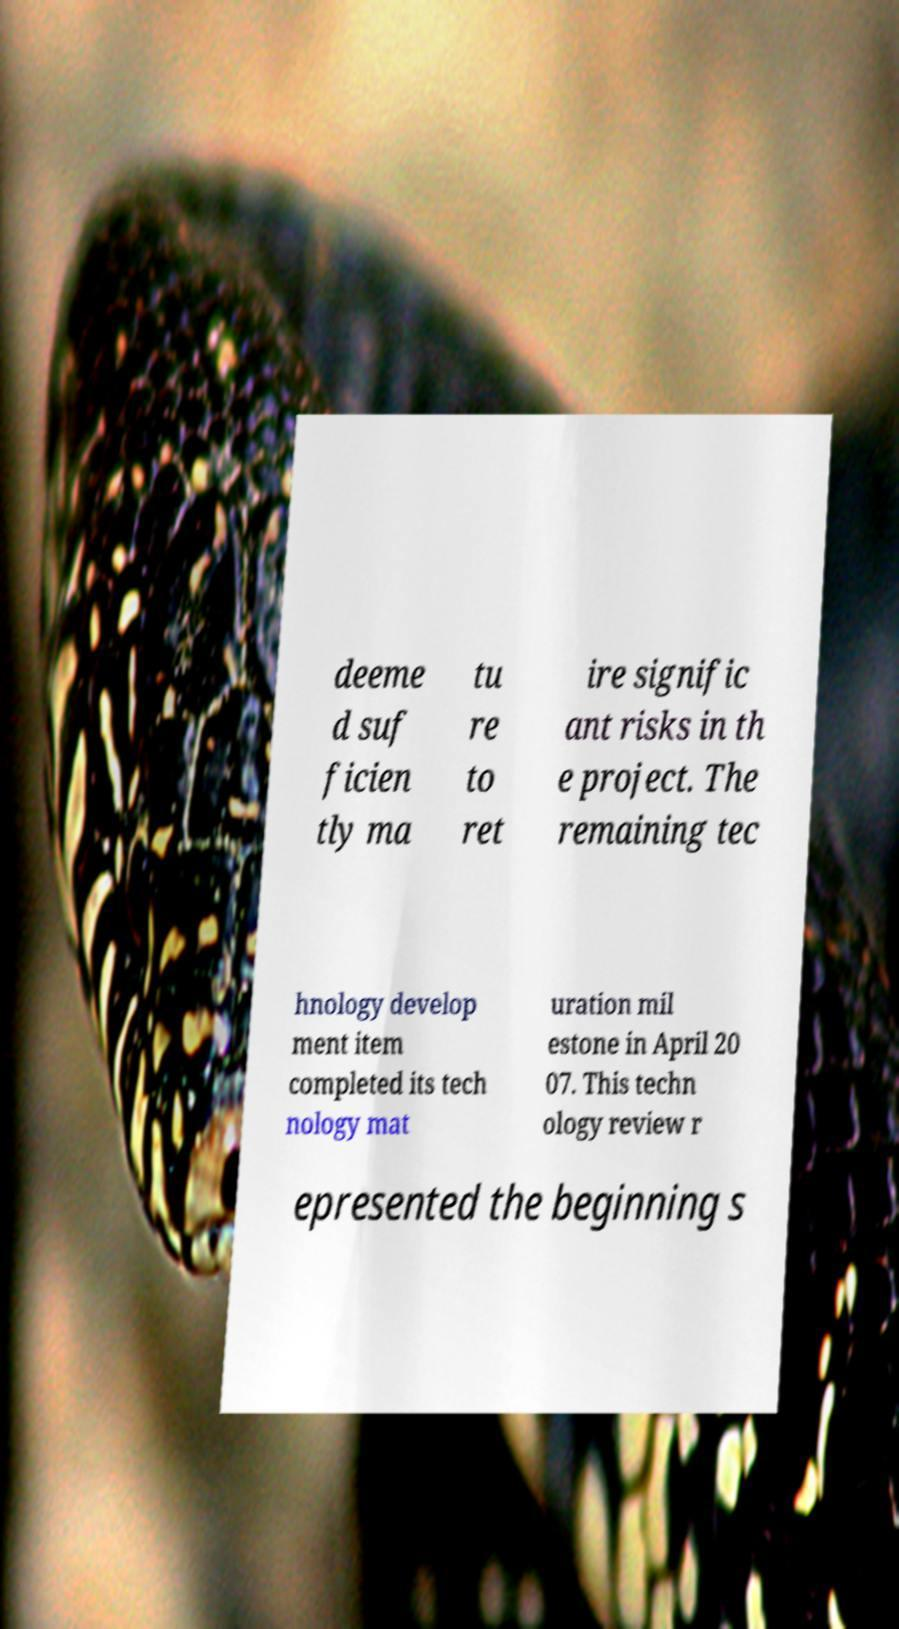Can you read and provide the text displayed in the image?This photo seems to have some interesting text. Can you extract and type it out for me? deeme d suf ficien tly ma tu re to ret ire signific ant risks in th e project. The remaining tec hnology develop ment item completed its tech nology mat uration mil estone in April 20 07. This techn ology review r epresented the beginning s 